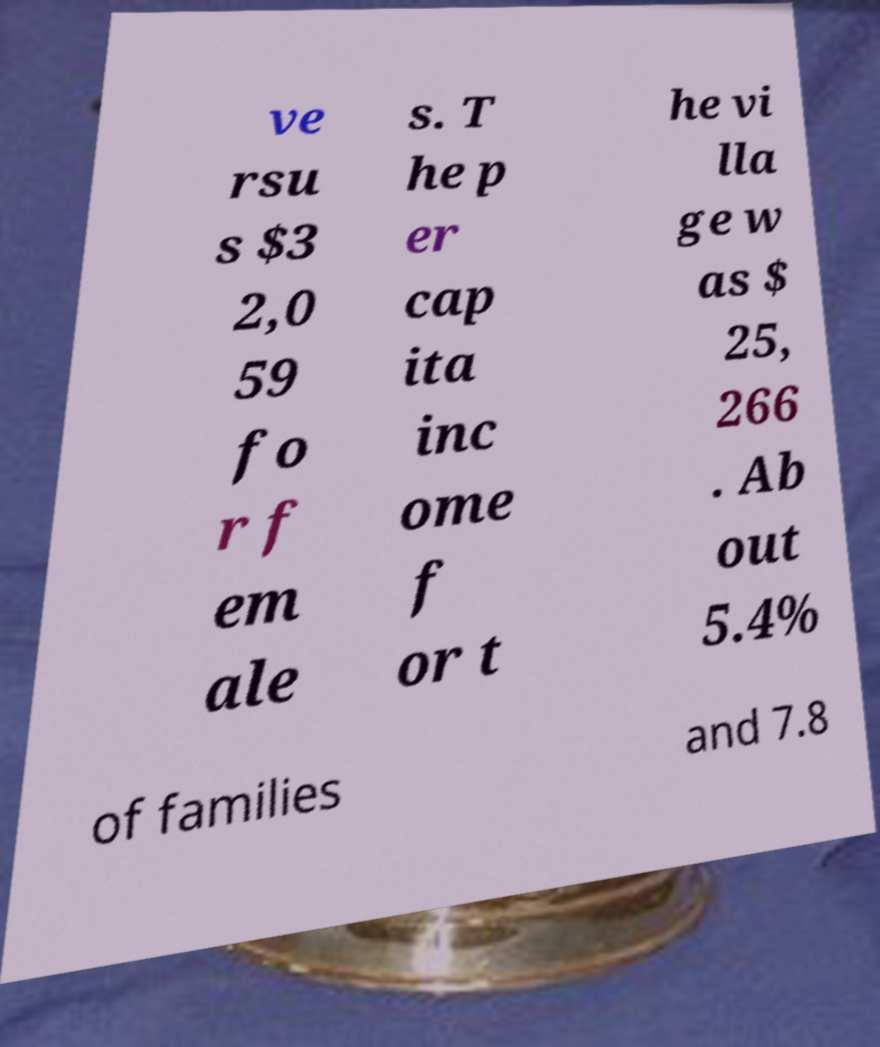I need the written content from this picture converted into text. Can you do that? ve rsu s $3 2,0 59 fo r f em ale s. T he p er cap ita inc ome f or t he vi lla ge w as $ 25, 266 . Ab out 5.4% of families and 7.8 